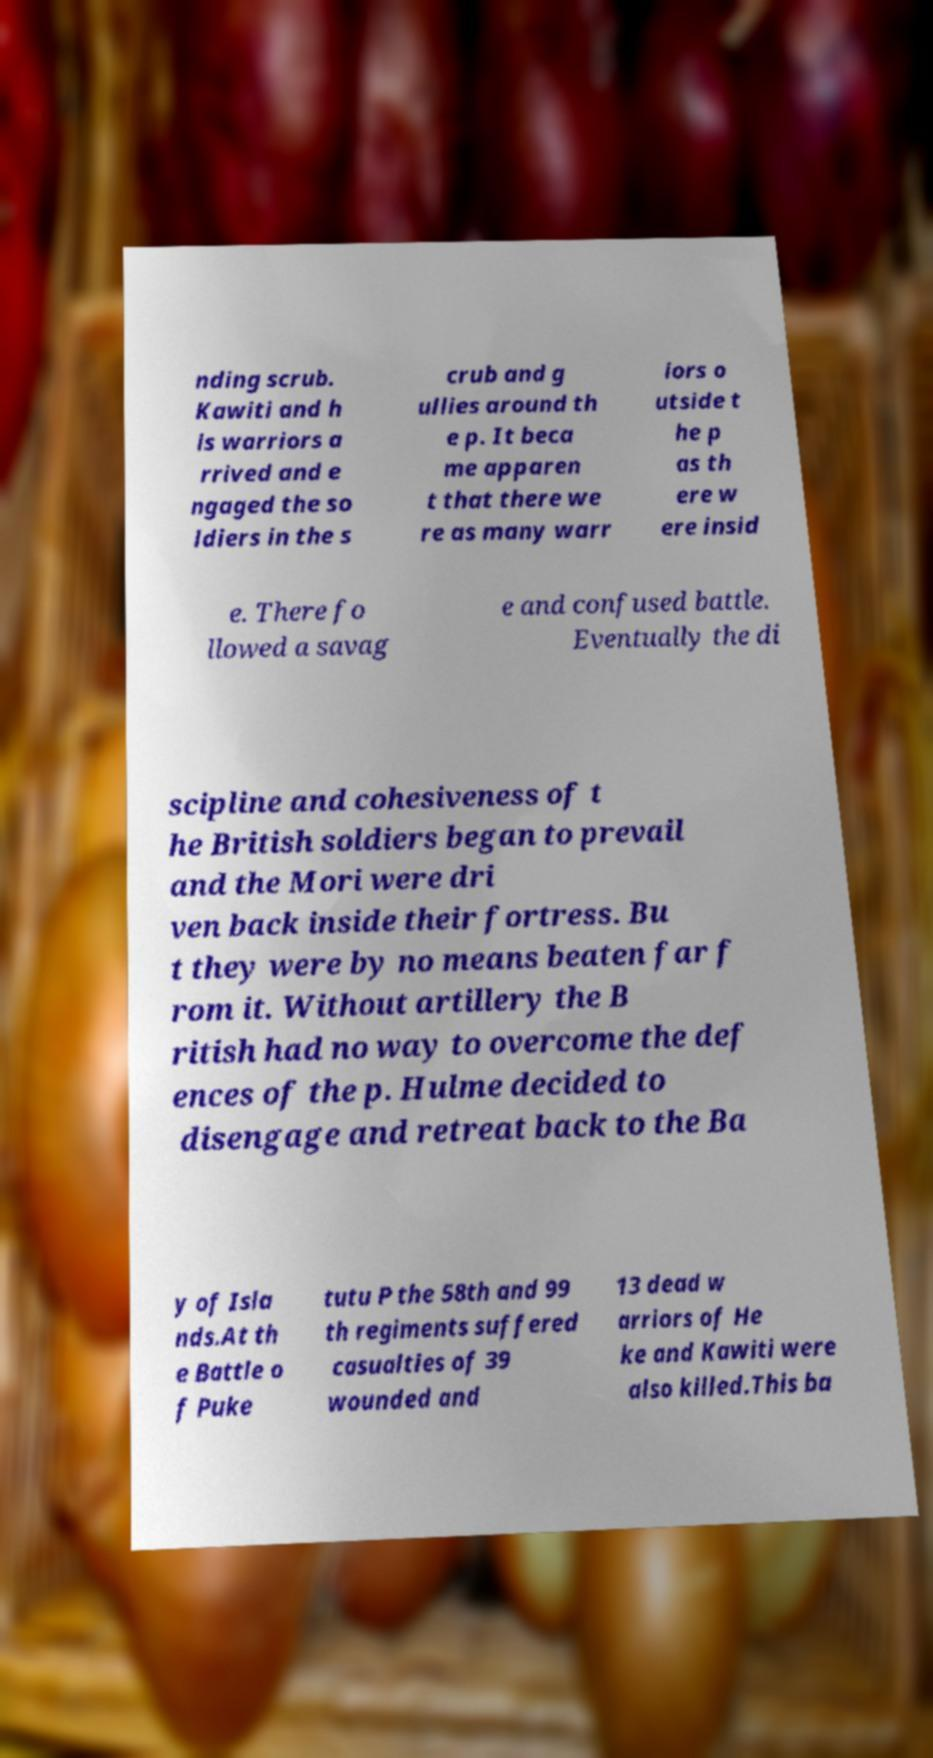Please read and relay the text visible in this image. What does it say? nding scrub. Kawiti and h is warriors a rrived and e ngaged the so ldiers in the s crub and g ullies around th e p. It beca me apparen t that there we re as many warr iors o utside t he p as th ere w ere insid e. There fo llowed a savag e and confused battle. Eventually the di scipline and cohesiveness of t he British soldiers began to prevail and the Mori were dri ven back inside their fortress. Bu t they were by no means beaten far f rom it. Without artillery the B ritish had no way to overcome the def ences of the p. Hulme decided to disengage and retreat back to the Ba y of Isla nds.At th e Battle o f Puke tutu P the 58th and 99 th regiments suffered casualties of 39 wounded and 13 dead w arriors of He ke and Kawiti were also killed.This ba 